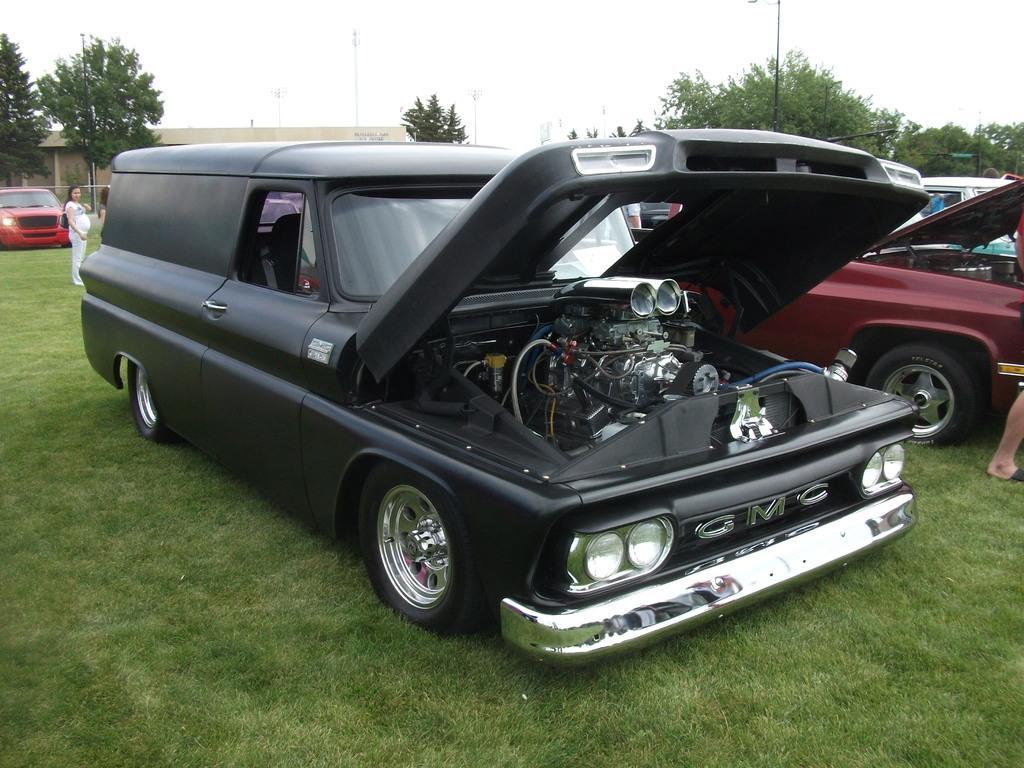Describe this image in one or two sentences. In this picture there are different types of cars. On the right side of the image there is a person standing beside the vehicle. On the left side of the image there is a person standing behind the vehicle. At the back there is a building and there are trees and poles. At the top there is sky. At the bottom there is grass. 